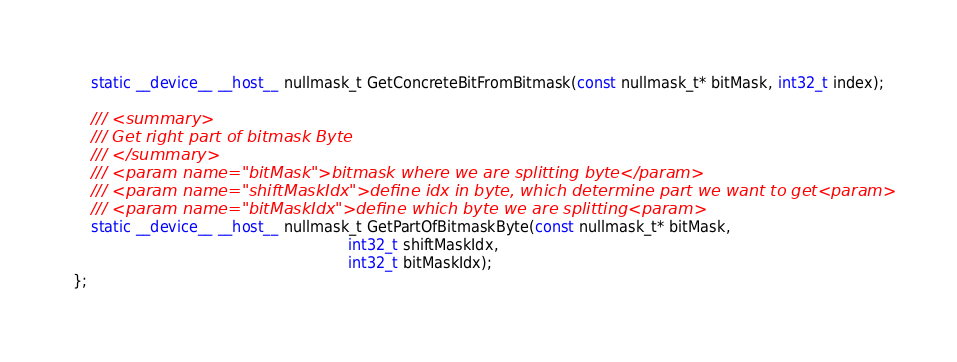Convert code to text. <code><loc_0><loc_0><loc_500><loc_500><_Cuda_>    static __device__ __host__ nullmask_t GetConcreteBitFromBitmask(const nullmask_t* bitMask, int32_t index);

	/// <summary>
    /// Get right part of bitmask Byte
    /// </summary>
    /// <param name="bitMask">bitmask where we are splitting byte</param>
    /// <param name="shiftMaskIdx">define idx in byte, which determine part we want to get<param>
    /// <param name="bitMaskIdx">define which byte we are splitting<param>
    static __device__ __host__ nullmask_t GetPartOfBitmaskByte(const nullmask_t* bitMask,
                                                            int32_t shiftMaskIdx,
                                                            int32_t bitMaskIdx);
};</code> 